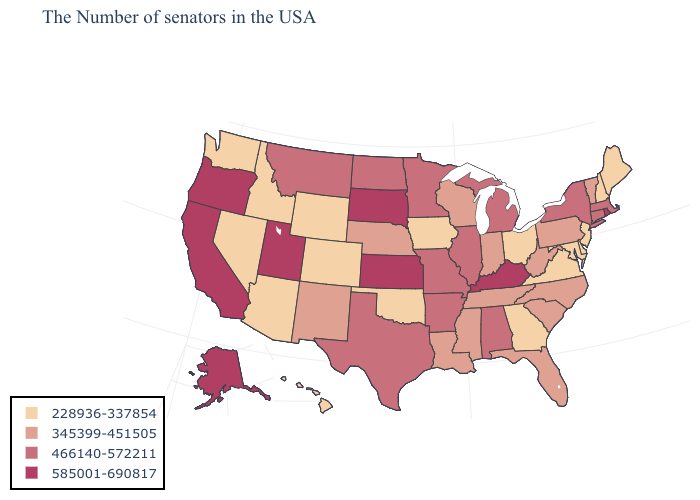Which states have the lowest value in the USA?
Keep it brief. Maine, New Hampshire, New Jersey, Delaware, Maryland, Virginia, Ohio, Georgia, Iowa, Oklahoma, Wyoming, Colorado, Arizona, Idaho, Nevada, Washington, Hawaii. What is the value of Alaska?
Be succinct. 585001-690817. Does the first symbol in the legend represent the smallest category?
Keep it brief. Yes. Does Colorado have the lowest value in the USA?
Give a very brief answer. Yes. Does the first symbol in the legend represent the smallest category?
Answer briefly. Yes. What is the highest value in the USA?
Answer briefly. 585001-690817. What is the highest value in the Northeast ?
Quick response, please. 585001-690817. What is the highest value in the South ?
Give a very brief answer. 585001-690817. What is the value of Mississippi?
Concise answer only. 345399-451505. Name the states that have a value in the range 345399-451505?
Short answer required. Vermont, Pennsylvania, North Carolina, South Carolina, West Virginia, Florida, Indiana, Tennessee, Wisconsin, Mississippi, Louisiana, Nebraska, New Mexico. What is the lowest value in states that border Ohio?
Keep it brief. 345399-451505. Does Delaware have the lowest value in the USA?
Give a very brief answer. Yes. Does Louisiana have the same value as Tennessee?
Be succinct. Yes. What is the value of North Dakota?
Keep it brief. 466140-572211. What is the value of Massachusetts?
Write a very short answer. 466140-572211. 